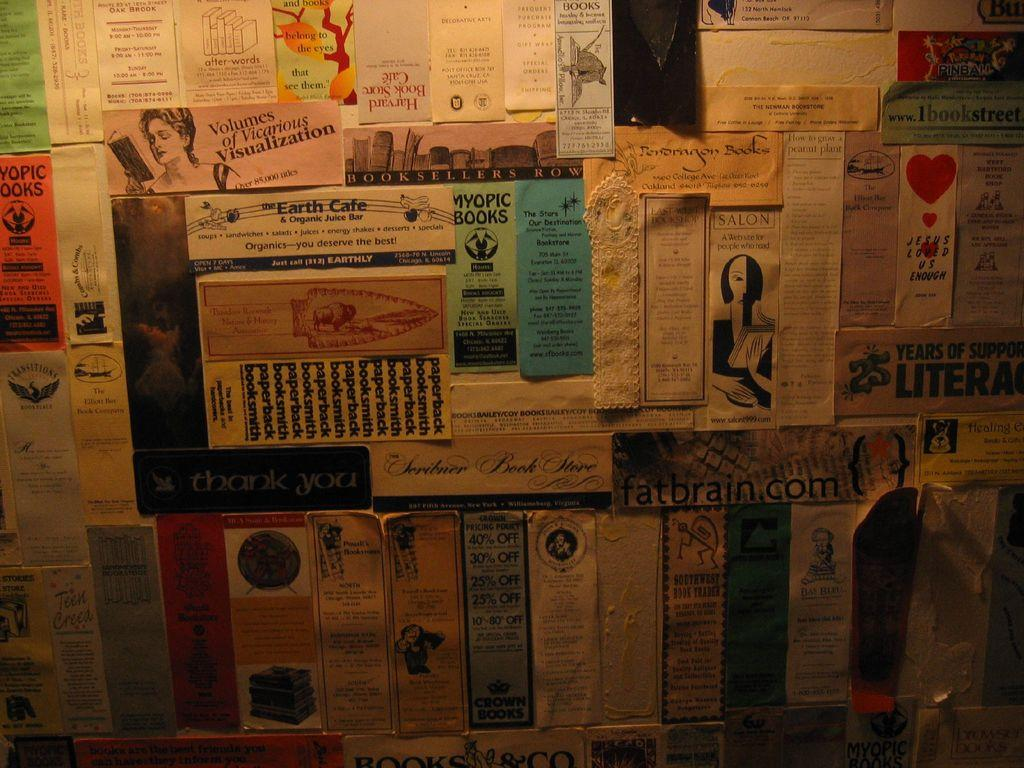<image>
Create a compact narrative representing the image presented. A wall is crowded with flyers, posters, and bookmarks, and features names like fatbrain.com, Myopic Books, and Southwest Book Trader. 